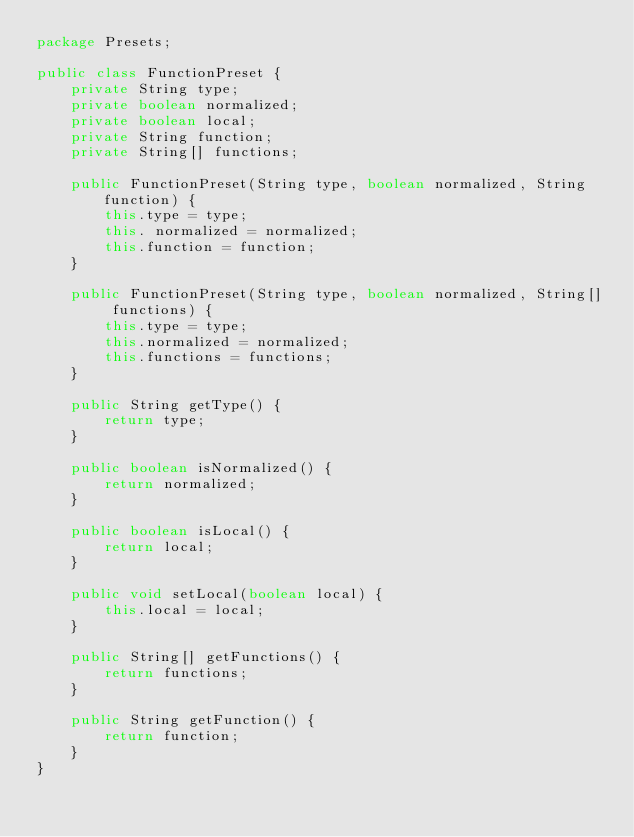Convert code to text. <code><loc_0><loc_0><loc_500><loc_500><_Java_>package Presets;

public class FunctionPreset {
    private String type;
    private boolean normalized;
    private boolean local;
    private String function;
    private String[] functions;

    public FunctionPreset(String type, boolean normalized, String function) {
        this.type = type;
        this. normalized = normalized;
        this.function = function;
    }

    public FunctionPreset(String type, boolean normalized, String[] functions) {
        this.type = type;
        this.normalized = normalized;
        this.functions = functions;
    }

    public String getType() {
        return type;
    }

    public boolean isNormalized() {
        return normalized;
    }

    public boolean isLocal() {
        return local;
    }

    public void setLocal(boolean local) {
        this.local = local;
    }

    public String[] getFunctions() {
        return functions;
    }

    public String getFunction() {
        return function;
    }
}
</code> 